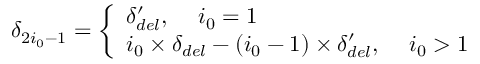<formula> <loc_0><loc_0><loc_500><loc_500>\delta _ { 2 i _ { 0 } - 1 } = \left \{ \begin{array} { l l } { \delta _ { d e l } ^ { \prime } , \, \ i _ { 0 } = 1 } \\ { i _ { 0 } \times \delta _ { d e l } - ( i _ { 0 } - 1 ) \times \delta _ { d e l } ^ { \prime } , \, \ i _ { 0 } > 1 } \end{array}</formula> 